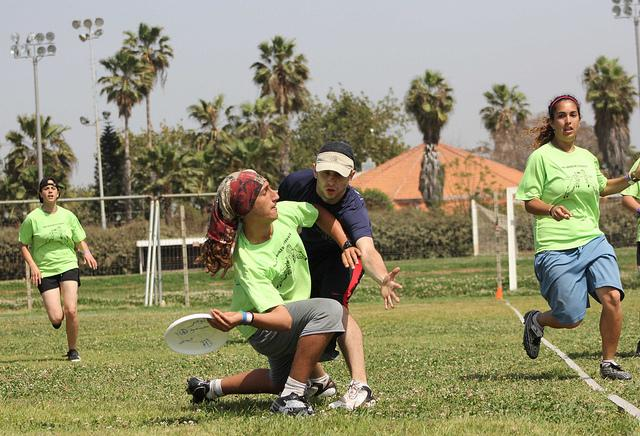The players are wearing the same shirts because they play in a what? Please explain your reasoning. league. The players are part of a team. 